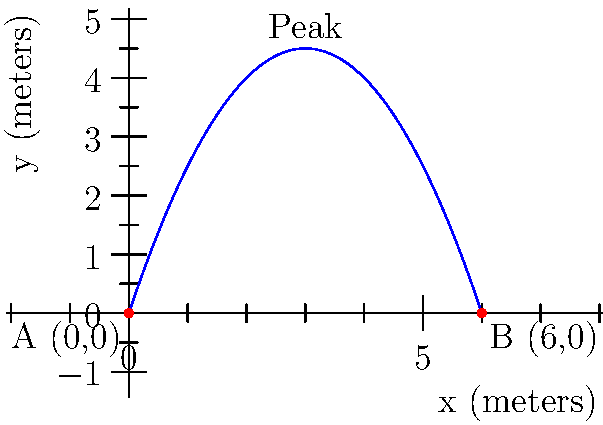A dancer performs a grand jeté (a long horizontal jump) across the stage. The trajectory of the dancer's center of mass can be modeled by the quadratic function $f(x) = -0.5x^2 + 3x$, where $x$ is the horizontal distance in meters and $f(x)$ is the height in meters. The dancer starts at point A (0,0) and lands at point B (6,0). What is the maximum height reached by the dancer during this leap? To find the maximum height of the dancer's leap, we need to follow these steps:

1) The function describing the trajectory is $f(x) = -0.5x^2 + 3x$.

2) To find the maximum point, we need to find the vertex of this parabola. For a quadratic function in the form $f(x) = ax^2 + bx + c$, the x-coordinate of the vertex is given by $x = -\frac{b}{2a}$.

3) In our case, $a = -0.5$ and $b = 3$. So:

   $x = -\frac{3}{2(-0.5)} = -\frac{3}{-1} = 3$

4) This means the peak of the jump occurs when $x = 3$ meters.

5) To find the height at this point, we substitute $x = 3$ into our original function:

   $f(3) = -0.5(3)^2 + 3(3)$
   $= -0.5(9) + 9$
   $= -4.5 + 9$
   $= 4.5$

Therefore, the maximum height reached by the dancer is 4.5 meters.
Answer: 4.5 meters 